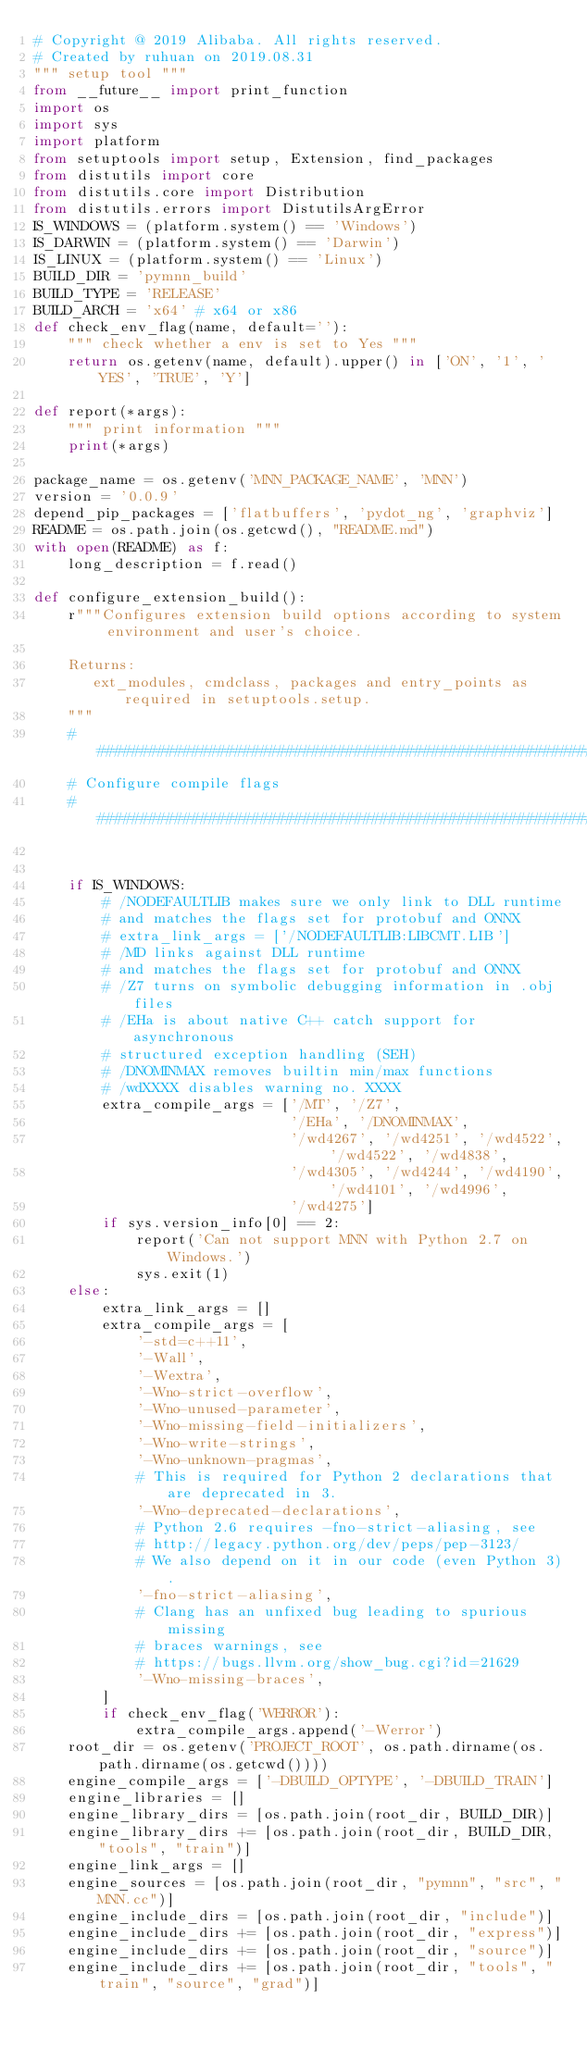Convert code to text. <code><loc_0><loc_0><loc_500><loc_500><_Python_># Copyright @ 2019 Alibaba. All rights reserved.
# Created by ruhuan on 2019.08.31
""" setup tool """
from __future__ import print_function
import os
import sys
import platform
from setuptools import setup, Extension, find_packages
from distutils import core
from distutils.core import Distribution
from distutils.errors import DistutilsArgError
IS_WINDOWS = (platform.system() == 'Windows')
IS_DARWIN = (platform.system() == 'Darwin')
IS_LINUX = (platform.system() == 'Linux')
BUILD_DIR = 'pymnn_build'
BUILD_TYPE = 'RELEASE'
BUILD_ARCH = 'x64' # x64 or x86
def check_env_flag(name, default=''):
    """ check whether a env is set to Yes """
    return os.getenv(name, default).upper() in ['ON', '1', 'YES', 'TRUE', 'Y']

def report(*args):
    """ print information """
    print(*args)

package_name = os.getenv('MNN_PACKAGE_NAME', 'MNN')
version = '0.0.9'
depend_pip_packages = ['flatbuffers', 'pydot_ng', 'graphviz']
README = os.path.join(os.getcwd(), "README.md")
with open(README) as f:
    long_description = f.read()

def configure_extension_build():
    r"""Configures extension build options according to system environment and user's choice.

    Returns:
       ext_modules, cmdclass, packages and entry_points as required in setuptools.setup.
    """
    ################################################################################
    # Configure compile flags
    ################################################################################


    if IS_WINDOWS:
        # /NODEFAULTLIB makes sure we only link to DLL runtime
        # and matches the flags set for protobuf and ONNX
        # extra_link_args = ['/NODEFAULTLIB:LIBCMT.LIB']
        # /MD links against DLL runtime
        # and matches the flags set for protobuf and ONNX
        # /Z7 turns on symbolic debugging information in .obj files
        # /EHa is about native C++ catch support for asynchronous
        # structured exception handling (SEH)
        # /DNOMINMAX removes builtin min/max functions
        # /wdXXXX disables warning no. XXXX
        extra_compile_args = ['/MT', '/Z7',
                              '/EHa', '/DNOMINMAX',
                              '/wd4267', '/wd4251', '/wd4522', '/wd4522', '/wd4838',
                              '/wd4305', '/wd4244', '/wd4190', '/wd4101', '/wd4996',
                              '/wd4275']
        if sys.version_info[0] == 2:
            report('Can not support MNN with Python 2.7 on Windows.')
            sys.exit(1)
    else:
        extra_link_args = []
        extra_compile_args = [
            '-std=c++11',
            '-Wall',
            '-Wextra',
            '-Wno-strict-overflow',
            '-Wno-unused-parameter',
            '-Wno-missing-field-initializers',
            '-Wno-write-strings',
            '-Wno-unknown-pragmas',
            # This is required for Python 2 declarations that are deprecated in 3.
            '-Wno-deprecated-declarations',
            # Python 2.6 requires -fno-strict-aliasing, see
            # http://legacy.python.org/dev/peps/pep-3123/
            # We also depend on it in our code (even Python 3).
            '-fno-strict-aliasing',
            # Clang has an unfixed bug leading to spurious missing
            # braces warnings, see
            # https://bugs.llvm.org/show_bug.cgi?id=21629
            '-Wno-missing-braces',
        ]
        if check_env_flag('WERROR'):
            extra_compile_args.append('-Werror')
    root_dir = os.getenv('PROJECT_ROOT', os.path.dirname(os.path.dirname(os.getcwd())))
    engine_compile_args = ['-DBUILD_OPTYPE', '-DBUILD_TRAIN']
    engine_libraries = []
    engine_library_dirs = [os.path.join(root_dir, BUILD_DIR)]
    engine_library_dirs += [os.path.join(root_dir, BUILD_DIR, "tools", "train")]
    engine_link_args = []
    engine_sources = [os.path.join(root_dir, "pymnn", "src", "MNN.cc")]
    engine_include_dirs = [os.path.join(root_dir, "include")]
    engine_include_dirs += [os.path.join(root_dir, "express")]
    engine_include_dirs += [os.path.join(root_dir, "source")]
    engine_include_dirs += [os.path.join(root_dir, "tools", "train", "source", "grad")]</code> 